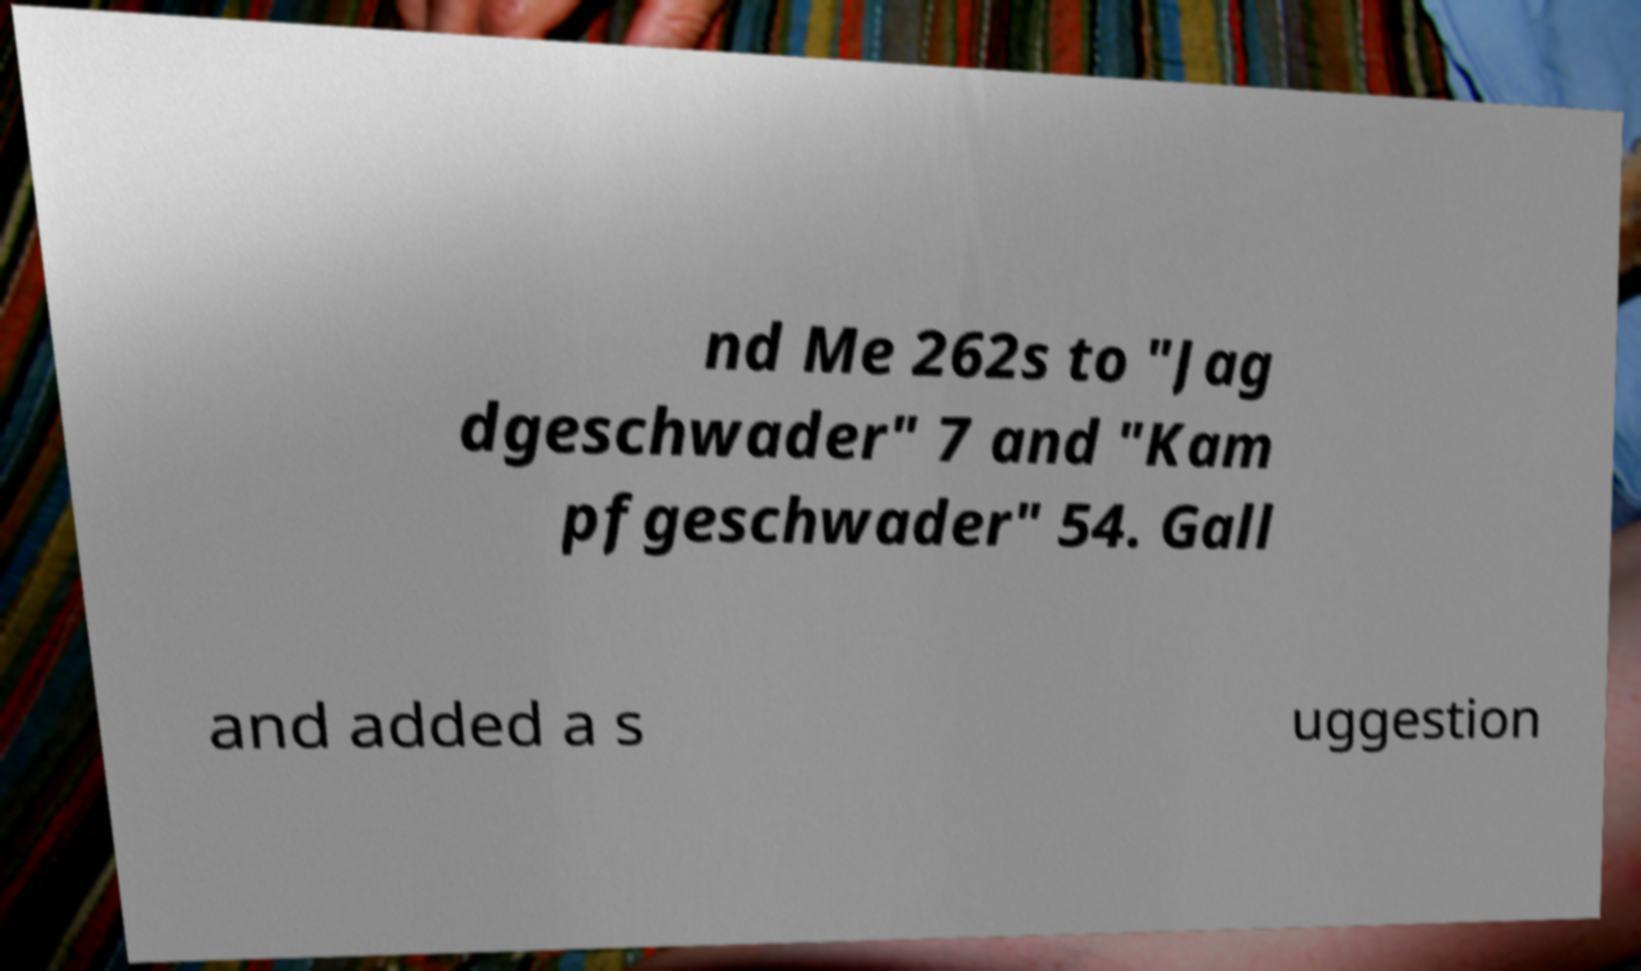Can you read and provide the text displayed in the image?This photo seems to have some interesting text. Can you extract and type it out for me? nd Me 262s to "Jag dgeschwader" 7 and "Kam pfgeschwader" 54. Gall and added a s uggestion 